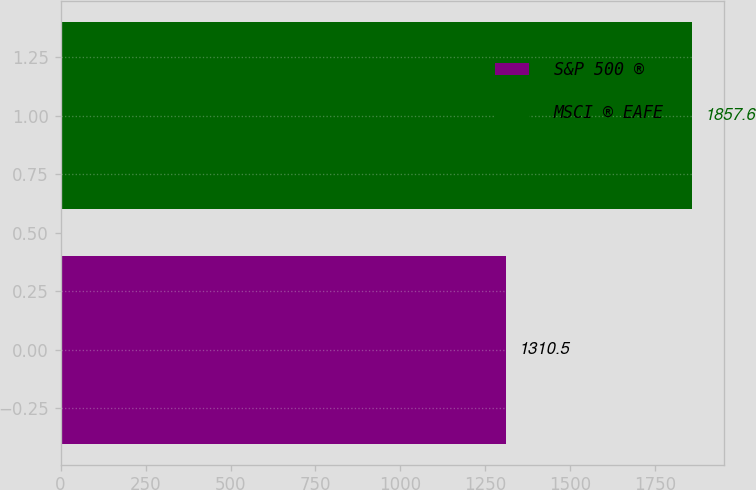Convert chart. <chart><loc_0><loc_0><loc_500><loc_500><bar_chart><fcel>S&P 500 ®<fcel>MSCI ® EAFE<nl><fcel>1310.5<fcel>1857.6<nl></chart> 